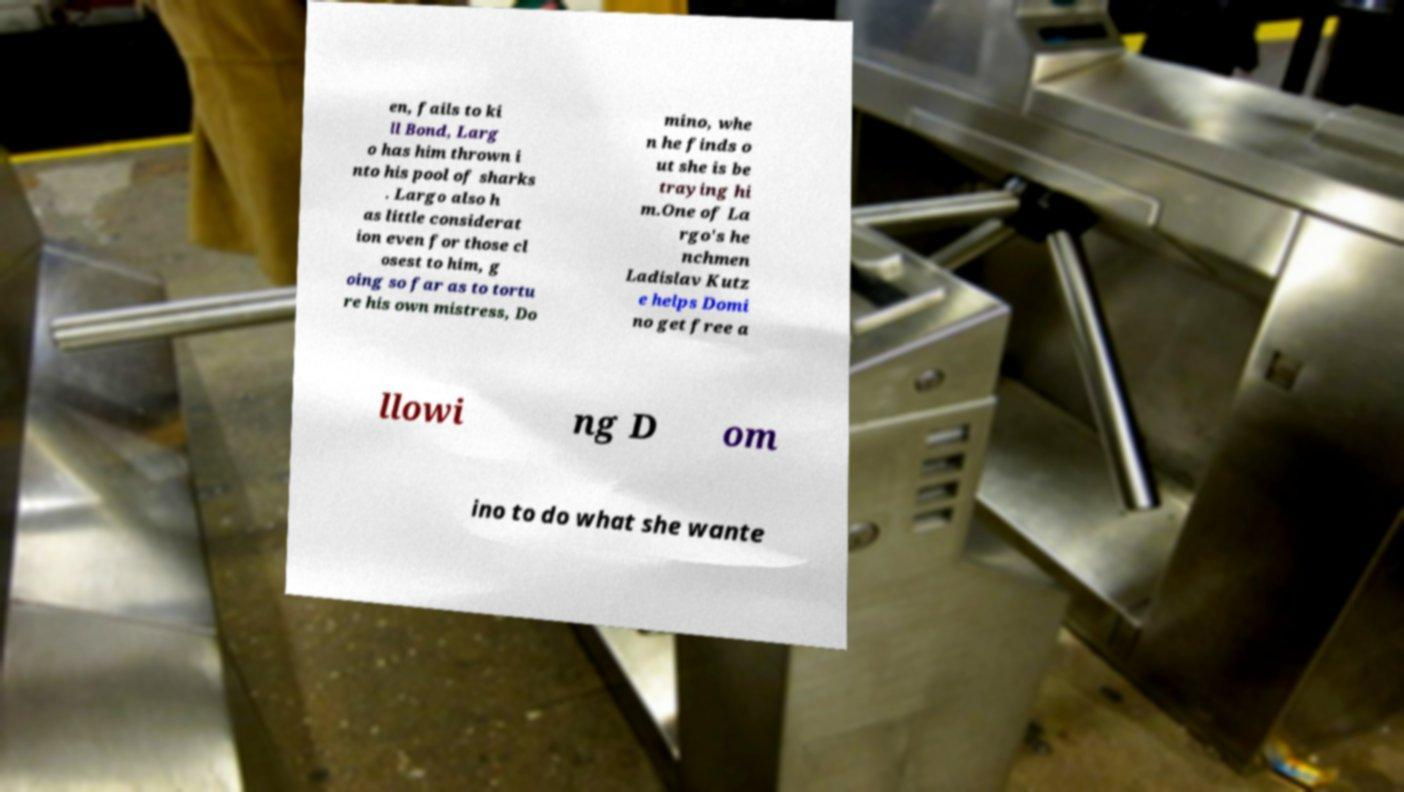There's text embedded in this image that I need extracted. Can you transcribe it verbatim? en, fails to ki ll Bond, Larg o has him thrown i nto his pool of sharks . Largo also h as little considerat ion even for those cl osest to him, g oing so far as to tortu re his own mistress, Do mino, whe n he finds o ut she is be traying hi m.One of La rgo's he nchmen Ladislav Kutz e helps Domi no get free a llowi ng D om ino to do what she wante 